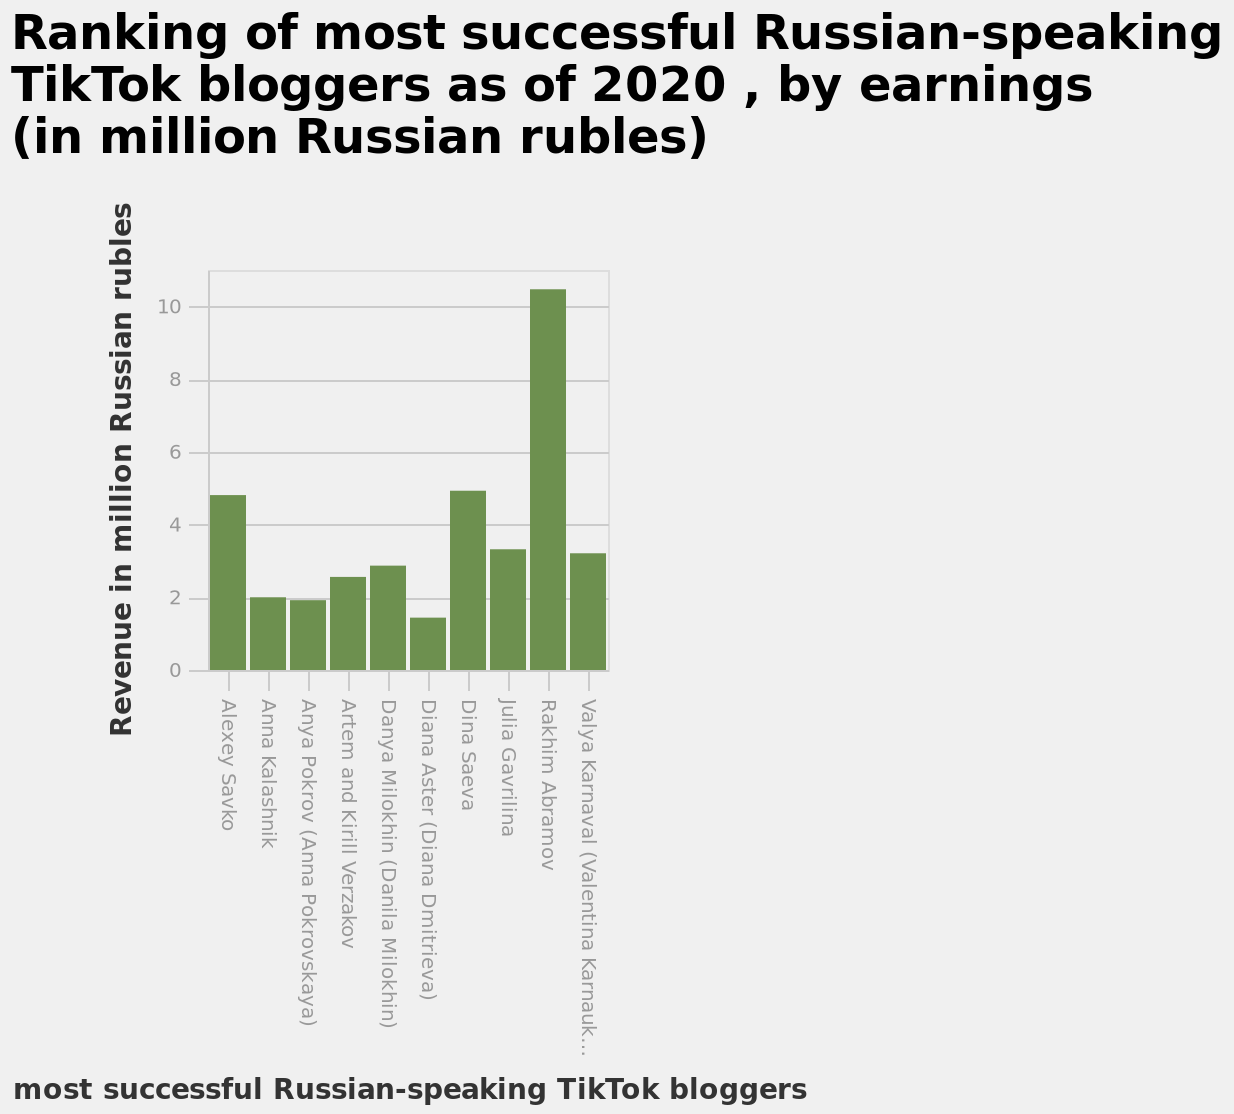<image>
please describe the details of the chart Here a is a bar plot titled Ranking of most successful Russian-speaking TikTok bloggers as of 2020 , by earnings (in million Russian rubles). The y-axis measures Revenue in million Russian rubles along linear scale with a minimum of 0 and a maximum of 10 while the x-axis shows most successful Russian-speaking TikTok bloggers along categorical scale starting with Alexey Savko and ending with Valya Karnaval (Valentina Karnaukhova). please summary the statistics and relations of the chart Rakhim Abramov earned the highest of the tiktokers with over 10 million Russian Rubles. Diana Aster (Diana Dmitrieva) earned the least of all the tiktokers with a little over 1 million Russian Rubles. Alexey Savko earned just a little below Dina Saeva who earned about 5 million Russian Rubles. What does the y-axis measure on the bar plot? The y-axis measures Revenue in million Russian rubles. 